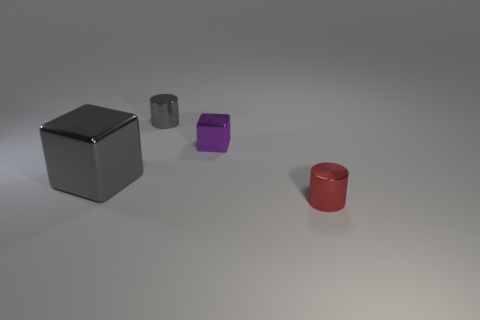What could be the possible function of these objects in a real-world setting? In a real-world setting, these objects could represent generic containers or storage units. The cube might be a large shipping container or storage bin, while the cylinders could be barrels used for storing liquids or other materials. Could the size difference indicate a specific sorting or organizational principle? Yes, the differing sizes and colors might suggest a sorting system based on content volume or category. For instance, the gray cube could be for larger items or a particular group of goods, while the red and purple cylinders could be coded to hold smaller quantities or different types of products. 